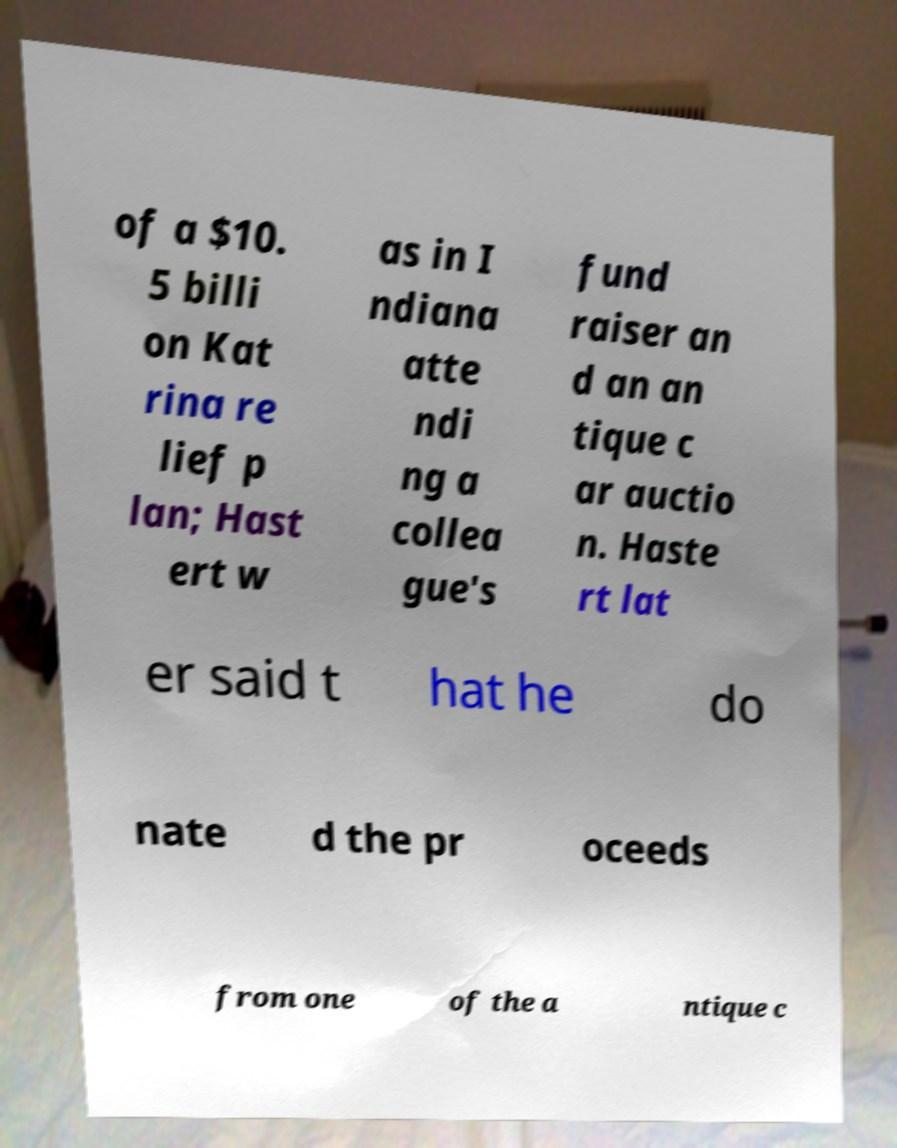I need the written content from this picture converted into text. Can you do that? of a $10. 5 billi on Kat rina re lief p lan; Hast ert w as in I ndiana atte ndi ng a collea gue's fund raiser an d an an tique c ar auctio n. Haste rt lat er said t hat he do nate d the pr oceeds from one of the a ntique c 